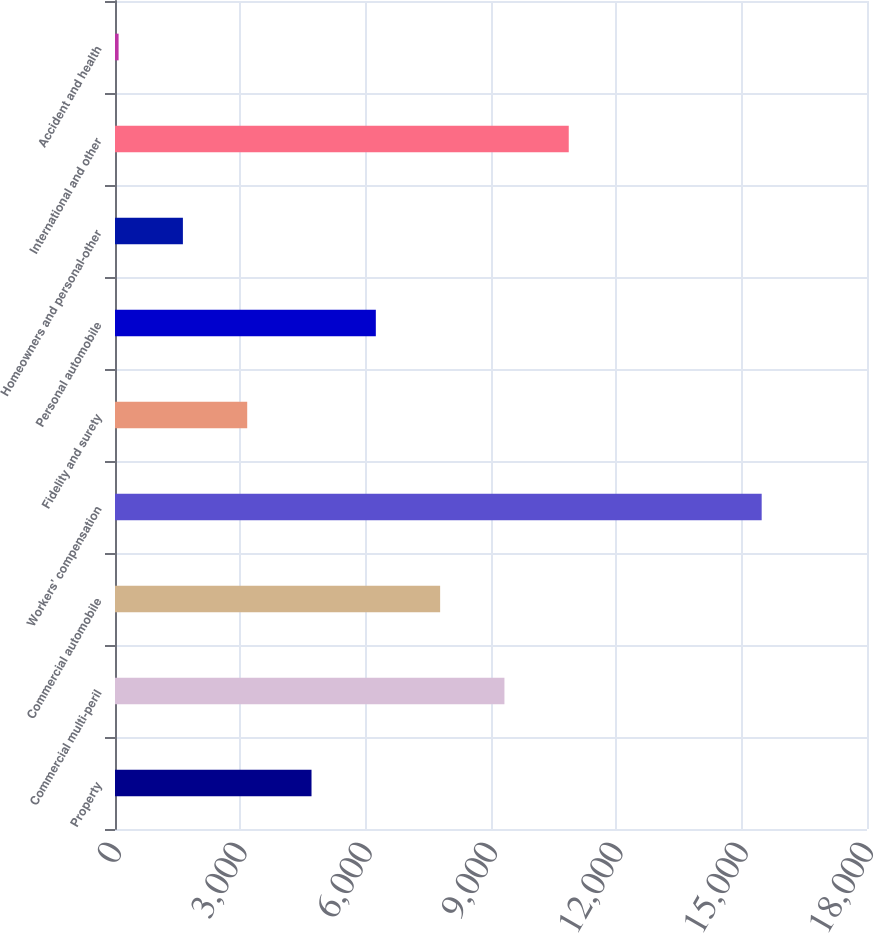<chart> <loc_0><loc_0><loc_500><loc_500><bar_chart><fcel>Property<fcel>Commercial multi-peril<fcel>Commercial automobile<fcel>Workers' compensation<fcel>Fidelity and surety<fcel>Personal automobile<fcel>Homeowners and personal-other<fcel>International and other<fcel>Accident and health<nl><fcel>4703.9<fcel>9321.8<fcel>7782.5<fcel>15479<fcel>3164.6<fcel>6243.2<fcel>1625.3<fcel>10861.1<fcel>86<nl></chart> 